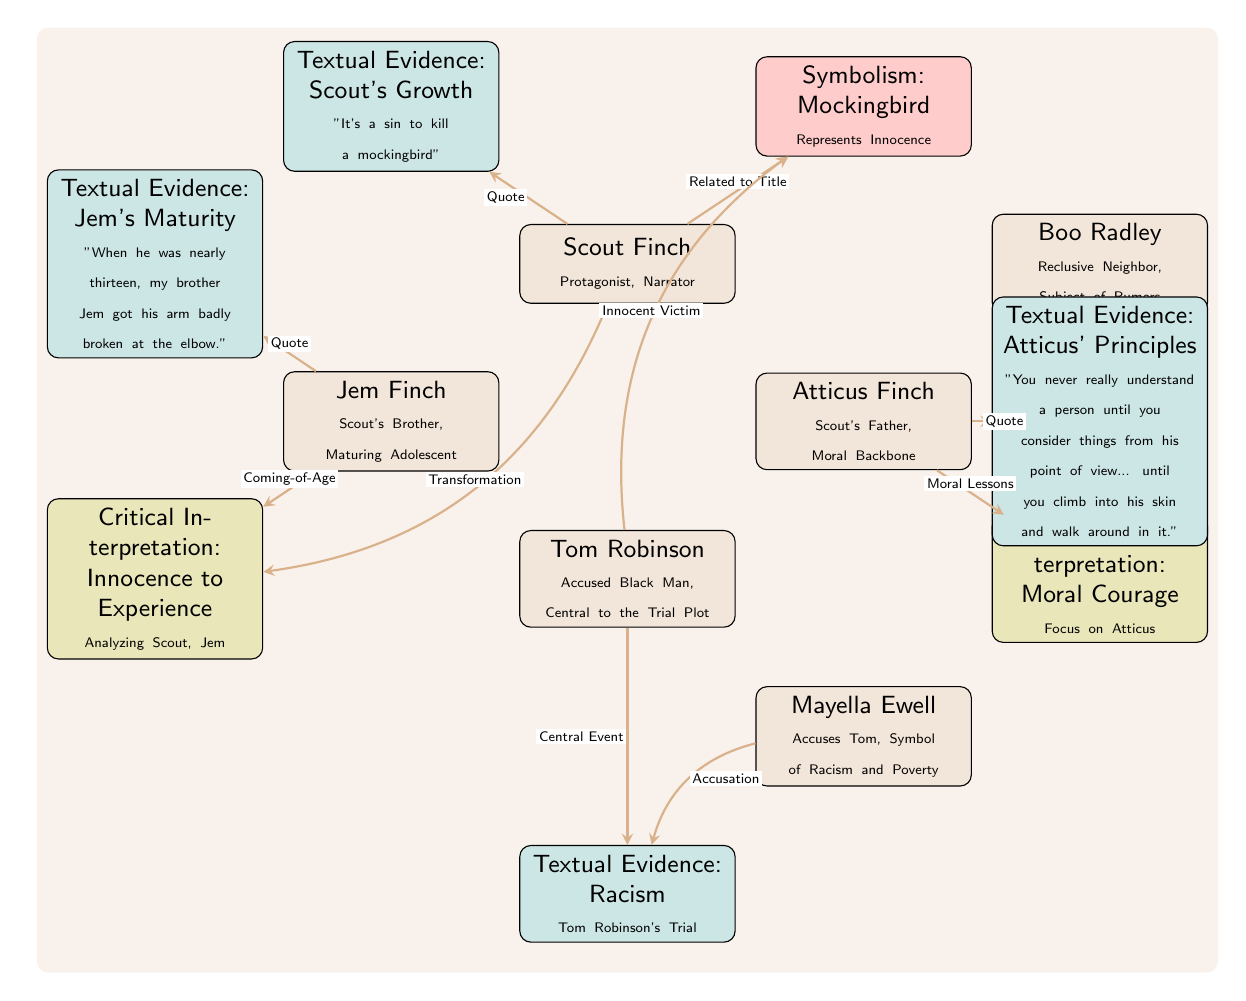What is the main symbolism represented in the diagram? The diagram indicates that the main symbolism is the Mockingbird, which is located in the "Symbolism" node. This node states that the mockingbird "Represents Innocence."
Answer: Mockingbird Who is the protagonist in 'To Kill a Mockingbird'? The diagram shows Scout Finch as the protagonist and narrator in the top-left node.
Answer: Scout Finch How many critical interpretations are presented in the diagram? There are two critical interpretations shown in the diagram: "Innocence to Experience" and "Moral Courage." Therefore, the count is 2.
Answer: 2 What relationship does Atticus Finch have with the theme of moral lessons? The diagram connects Atticus Finch (node) to the "Moral Lessons" label, indicating a direct relationship emphasizing his role.
Answer: Moral Lessons What textual evidence represents Jem's maturity in the diagram? The relevant quote regarding Jem's maturity is found in the "Textual Evidence" node that states, "When he was nearly thirteen, my brother Jem got his arm badly broken at the elbow."
Answer: Jem's Maturity How do Scout and Jem's character arcs relate according to the diagram? The diagram illustrates their character arcs transitioning from innocence to experience, highlighting their growth as they encounter various societal issues.
Answer: Innocence to Experience Which character is labeled as an "Innocent Victim" in the diagram? The diagram identifies Tom Robinson as the "Innocent Victim," reflected in the connecting edge to the "Mockingbird" symbolism.
Answer: Tom Robinson What is Boo Radley’s role as presented in the diagram? Boo Radley is described as a "Reclusive Neighbor, Subject of Rumors," placed in the upper right section of the diagram.
Answer: Reclusive Neighbor In which context is Mayella Ewell mentioned with respect to the racism theme? Mayella Ewell is connected to the "Racism" quote with the label "Accusation," indicating her crucial role in the racial tensions depicted in the narrative.
Answer: Accusation 